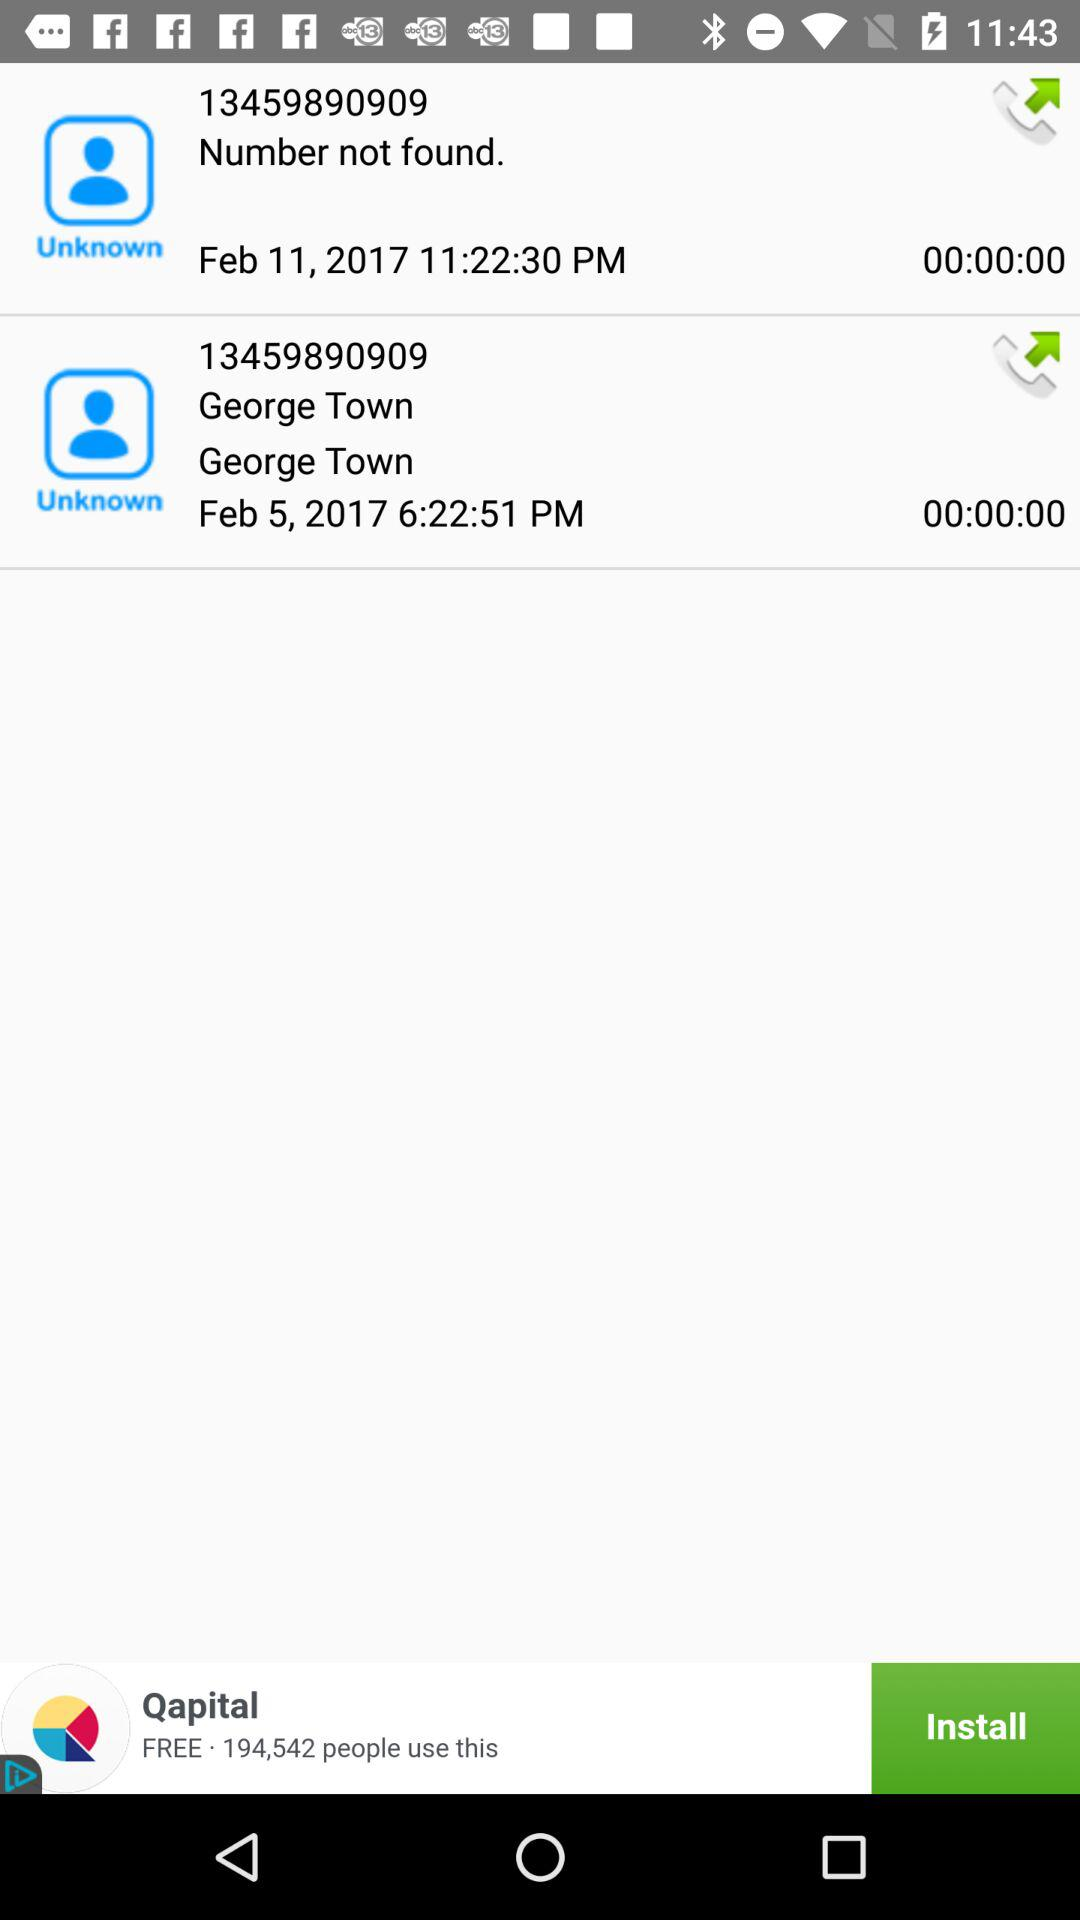What is George Town's number? George Town's number is 13459890909. 